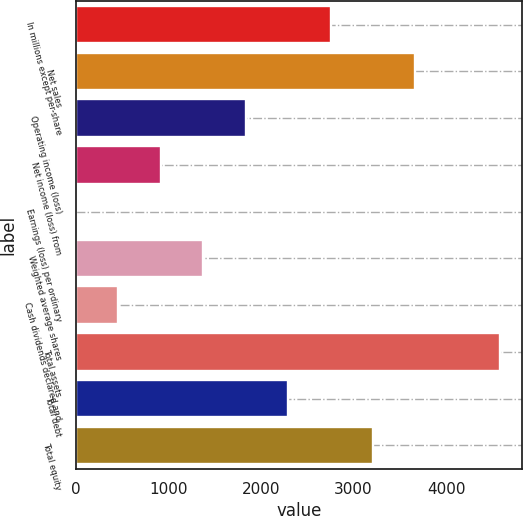<chart> <loc_0><loc_0><loc_500><loc_500><bar_chart><fcel>In millions except per-share<fcel>Net sales<fcel>Operating income (loss)<fcel>Net income (loss) from<fcel>Earnings (loss) per ordinary<fcel>Weighted average shares<fcel>Cash dividends declared and<fcel>Total assets<fcel>Total debt<fcel>Total equity<nl><fcel>2751.8<fcel>3669.04<fcel>1834.56<fcel>917.32<fcel>0.08<fcel>1375.94<fcel>458.7<fcel>4586.3<fcel>2293.18<fcel>3210.42<nl></chart> 